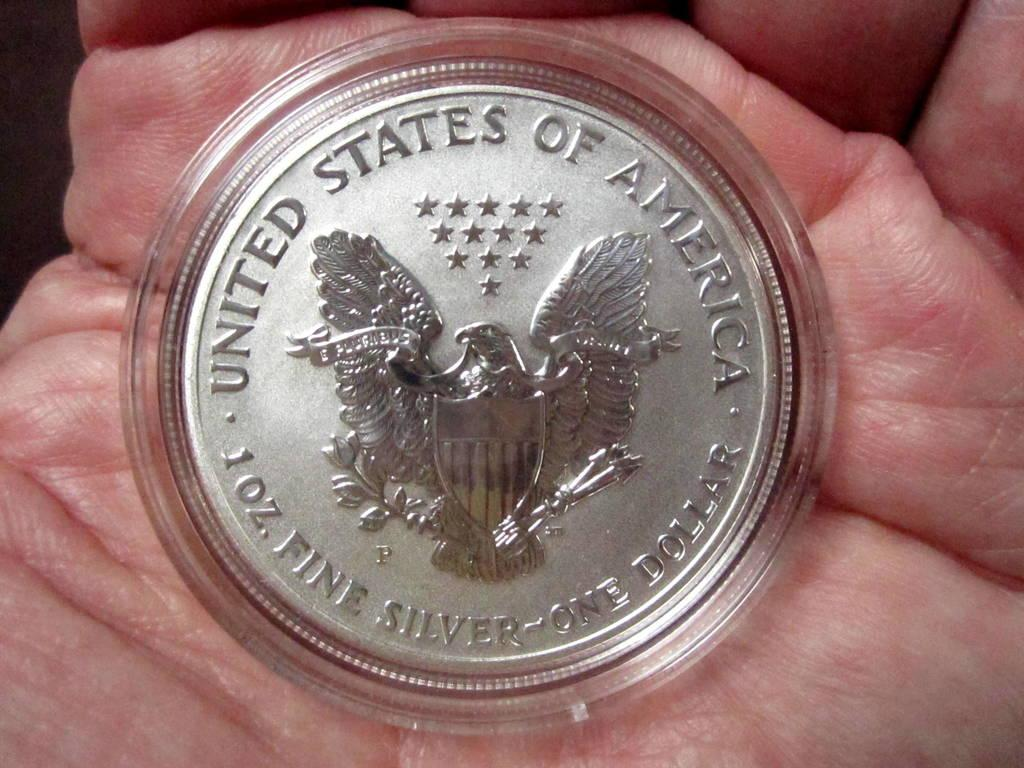Provide a one-sentence caption for the provided image. A person holding a silver coin that states 1 oz. fine silver. 